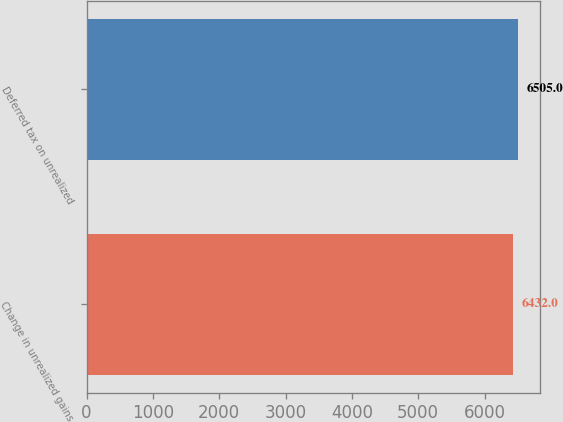Convert chart to OTSL. <chart><loc_0><loc_0><loc_500><loc_500><bar_chart><fcel>Change in unrealized gains<fcel>Deferred tax on unrealized<nl><fcel>6432<fcel>6505<nl></chart> 